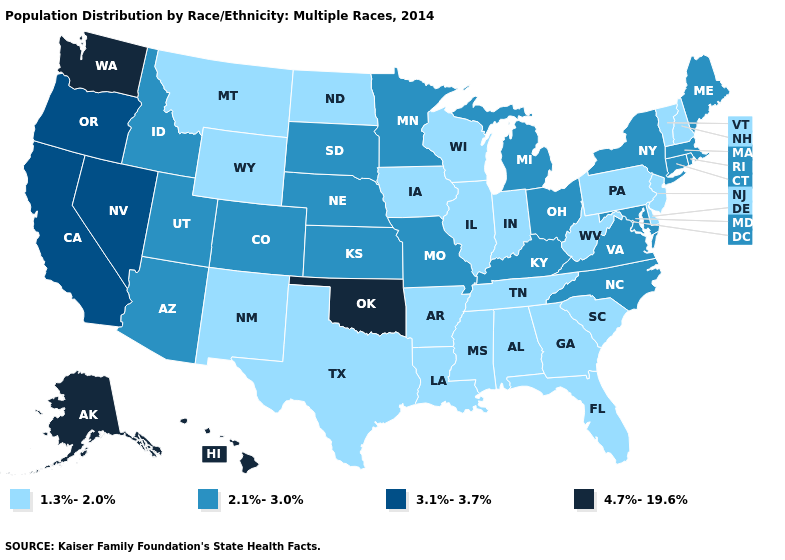Among the states that border Wyoming , which have the highest value?
Be succinct. Colorado, Idaho, Nebraska, South Dakota, Utah. Among the states that border Missouri , which have the highest value?
Short answer required. Oklahoma. Name the states that have a value in the range 1.3%-2.0%?
Give a very brief answer. Alabama, Arkansas, Delaware, Florida, Georgia, Illinois, Indiana, Iowa, Louisiana, Mississippi, Montana, New Hampshire, New Jersey, New Mexico, North Dakota, Pennsylvania, South Carolina, Tennessee, Texas, Vermont, West Virginia, Wisconsin, Wyoming. What is the value of Missouri?
Give a very brief answer. 2.1%-3.0%. Name the states that have a value in the range 2.1%-3.0%?
Answer briefly. Arizona, Colorado, Connecticut, Idaho, Kansas, Kentucky, Maine, Maryland, Massachusetts, Michigan, Minnesota, Missouri, Nebraska, New York, North Carolina, Ohio, Rhode Island, South Dakota, Utah, Virginia. Among the states that border Georgia , does North Carolina have the lowest value?
Give a very brief answer. No. Among the states that border Tennessee , which have the highest value?
Answer briefly. Kentucky, Missouri, North Carolina, Virginia. What is the highest value in states that border Louisiana?
Answer briefly. 1.3%-2.0%. Among the states that border Texas , which have the highest value?
Concise answer only. Oklahoma. Does Oklahoma have the highest value in the South?
Quick response, please. Yes. Is the legend a continuous bar?
Quick response, please. No. Name the states that have a value in the range 4.7%-19.6%?
Write a very short answer. Alaska, Hawaii, Oklahoma, Washington. What is the value of Utah?
Give a very brief answer. 2.1%-3.0%. Does Kentucky have the lowest value in the South?
Give a very brief answer. No. Does the first symbol in the legend represent the smallest category?
Write a very short answer. Yes. 